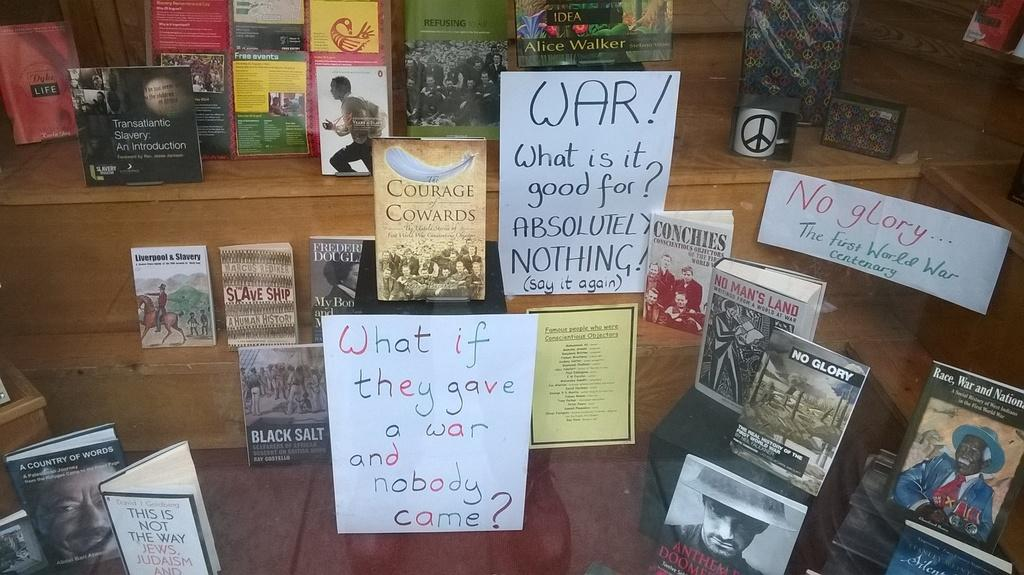What is on the glass in the image? There are posts on the glass. What can be seen in the background of the image? There are books in the background. Where are the books located? The books are on a platform. How are the books arranged on the platform? The books are arranged in a stepwise order. How many pickles are on the platform with the books? There are no pickles present in the image. What type of cattle can be seen grazing near the books? There are no cattle present in the image. 